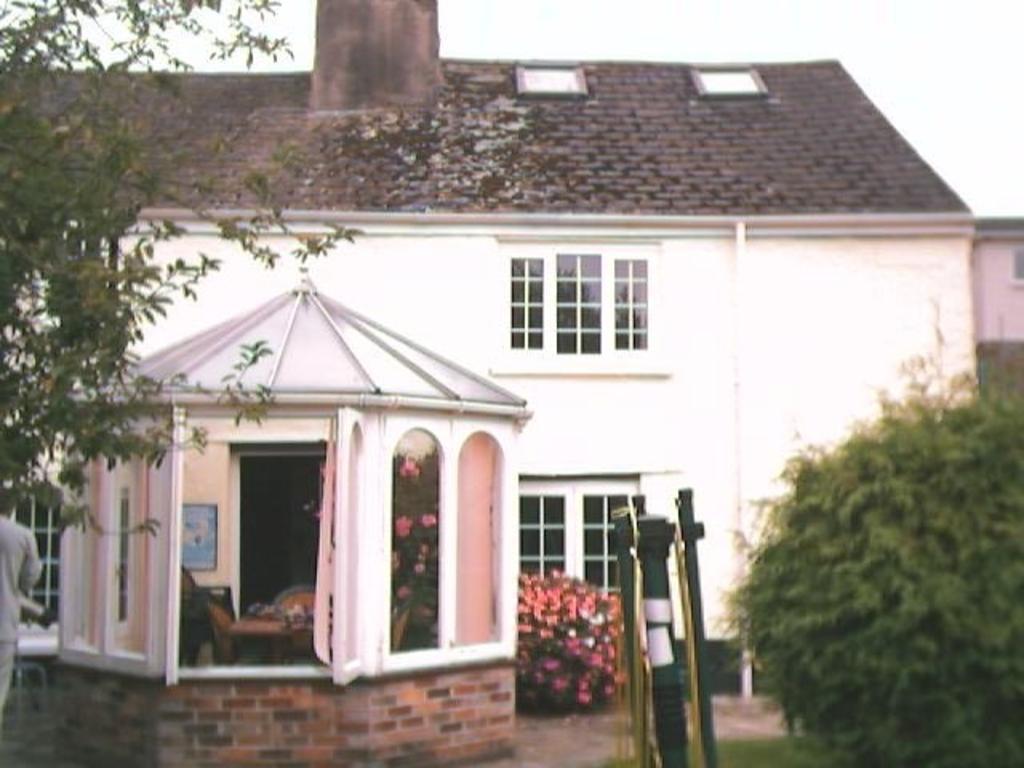Could you give a brief overview of what you see in this image? In this image in the center there is a building. On the left side there is a person and there is a tree. On the right side there is grass on the ground, there is an object which is black in colour, there is plant and there is a tree. 